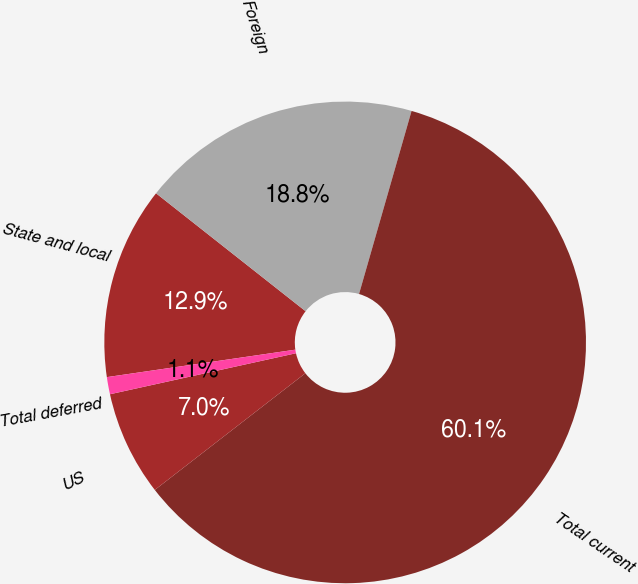Convert chart. <chart><loc_0><loc_0><loc_500><loc_500><pie_chart><fcel>State and local<fcel>Foreign<fcel>Total current<fcel>US<fcel>Total deferred<nl><fcel>12.93%<fcel>18.82%<fcel>60.06%<fcel>7.04%<fcel>1.15%<nl></chart> 